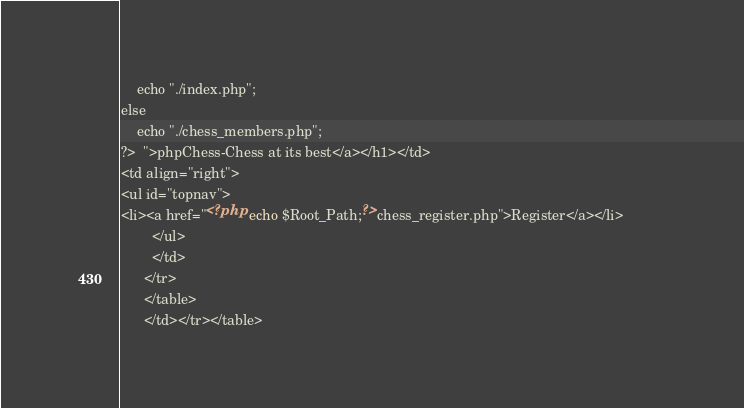Convert code to text. <code><loc_0><loc_0><loc_500><loc_500><_PHP_>	echo "./index.php";
else
	echo "./chess_members.php";
?>	">phpChess-Chess at its best</a></h1></td>
<td align="right">
<ul id="topnav">
<li><a href="<?php echo $Root_Path;?>chess_register.php">Register</a></li>           
        </ul>
        </td>
      </tr>
      </table>
      </td></tr></table>

</code> 